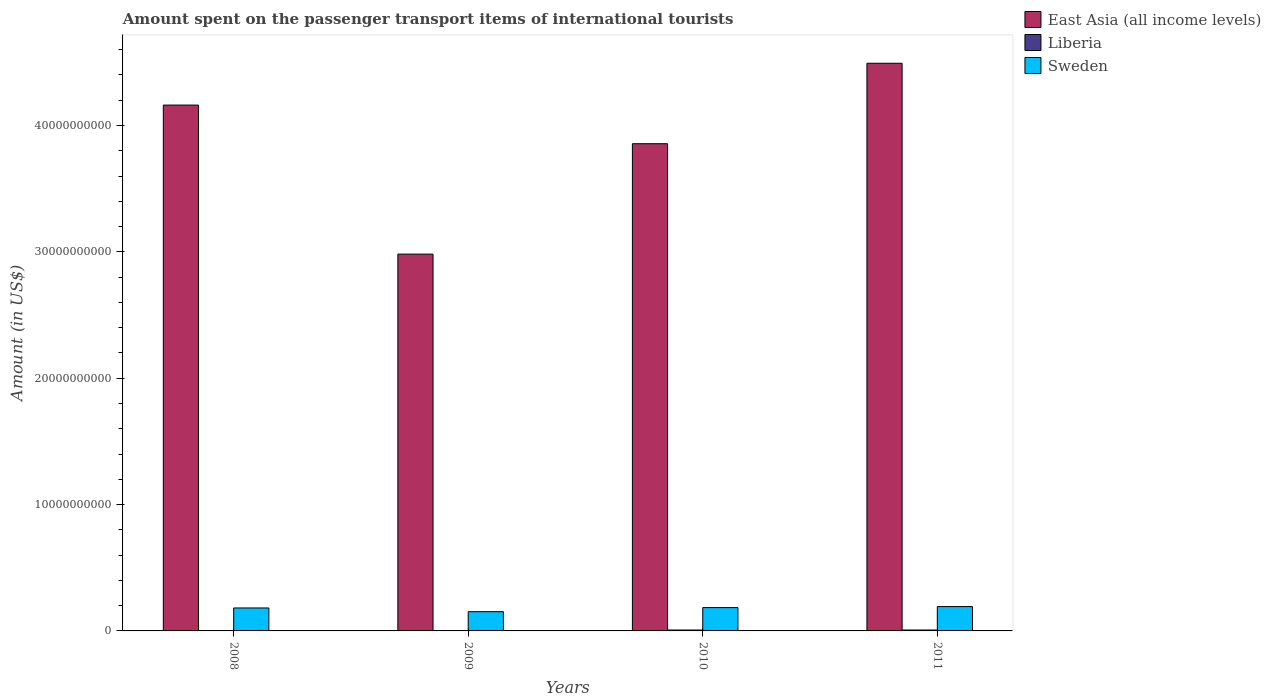Are the number of bars on each tick of the X-axis equal?
Offer a very short reply. Yes. How many bars are there on the 3rd tick from the left?
Offer a terse response. 3. What is the label of the 1st group of bars from the left?
Offer a terse response. 2008. What is the amount spent on the passenger transport items of international tourists in East Asia (all income levels) in 2008?
Your answer should be very brief. 4.16e+1. Across all years, what is the maximum amount spent on the passenger transport items of international tourists in Sweden?
Your response must be concise. 1.93e+09. Across all years, what is the minimum amount spent on the passenger transport items of international tourists in East Asia (all income levels)?
Your answer should be very brief. 2.98e+1. In which year was the amount spent on the passenger transport items of international tourists in Sweden maximum?
Give a very brief answer. 2011. What is the total amount spent on the passenger transport items of international tourists in Sweden in the graph?
Your response must be concise. 7.11e+09. What is the difference between the amount spent on the passenger transport items of international tourists in East Asia (all income levels) in 2010 and that in 2011?
Offer a very short reply. -6.37e+09. What is the difference between the amount spent on the passenger transport items of international tourists in East Asia (all income levels) in 2008 and the amount spent on the passenger transport items of international tourists in Sweden in 2010?
Make the answer very short. 3.98e+1. What is the average amount spent on the passenger transport items of international tourists in Liberia per year?
Provide a succinct answer. 4.82e+07. In the year 2009, what is the difference between the amount spent on the passenger transport items of international tourists in Liberia and amount spent on the passenger transport items of international tourists in Sweden?
Your answer should be very brief. -1.50e+09. In how many years, is the amount spent on the passenger transport items of international tourists in Sweden greater than 4000000000 US$?
Make the answer very short. 0. What is the ratio of the amount spent on the passenger transport items of international tourists in Sweden in 2008 to that in 2009?
Your response must be concise. 1.19. Is the amount spent on the passenger transport items of international tourists in East Asia (all income levels) in 2009 less than that in 2010?
Keep it short and to the point. Yes. Is the difference between the amount spent on the passenger transport items of international tourists in Liberia in 2009 and 2011 greater than the difference between the amount spent on the passenger transport items of international tourists in Sweden in 2009 and 2011?
Give a very brief answer. Yes. What is the difference between the highest and the second highest amount spent on the passenger transport items of international tourists in East Asia (all income levels)?
Ensure brevity in your answer.  3.31e+09. What is the difference between the highest and the lowest amount spent on the passenger transport items of international tourists in Sweden?
Provide a succinct answer. 4.03e+08. In how many years, is the amount spent on the passenger transport items of international tourists in Sweden greater than the average amount spent on the passenger transport items of international tourists in Sweden taken over all years?
Keep it short and to the point. 3. Is the sum of the amount spent on the passenger transport items of international tourists in East Asia (all income levels) in 2008 and 2011 greater than the maximum amount spent on the passenger transport items of international tourists in Liberia across all years?
Provide a short and direct response. Yes. What does the 2nd bar from the right in 2010 represents?
Provide a succinct answer. Liberia. How many bars are there?
Keep it short and to the point. 12. Are all the bars in the graph horizontal?
Your answer should be very brief. No. Are the values on the major ticks of Y-axis written in scientific E-notation?
Give a very brief answer. No. Does the graph contain any zero values?
Provide a succinct answer. No. Where does the legend appear in the graph?
Make the answer very short. Top right. What is the title of the graph?
Your answer should be compact. Amount spent on the passenger transport items of international tourists. Does "Euro area" appear as one of the legend labels in the graph?
Provide a short and direct response. No. What is the label or title of the Y-axis?
Offer a terse response. Amount (in US$). What is the Amount (in US$) in East Asia (all income levels) in 2008?
Your response must be concise. 4.16e+1. What is the Amount (in US$) in Liberia in 2008?
Offer a very short reply. 2.80e+07. What is the Amount (in US$) in Sweden in 2008?
Your answer should be compact. 1.82e+09. What is the Amount (in US$) in East Asia (all income levels) in 2009?
Provide a short and direct response. 2.98e+1. What is the Amount (in US$) in Liberia in 2009?
Your answer should be very brief. 2.20e+07. What is the Amount (in US$) of Sweden in 2009?
Ensure brevity in your answer.  1.52e+09. What is the Amount (in US$) of East Asia (all income levels) in 2010?
Offer a very short reply. 3.86e+1. What is the Amount (in US$) of Liberia in 2010?
Your response must be concise. 7.10e+07. What is the Amount (in US$) in Sweden in 2010?
Your answer should be very brief. 1.85e+09. What is the Amount (in US$) of East Asia (all income levels) in 2011?
Provide a short and direct response. 4.49e+1. What is the Amount (in US$) in Liberia in 2011?
Provide a short and direct response. 7.20e+07. What is the Amount (in US$) in Sweden in 2011?
Offer a terse response. 1.93e+09. Across all years, what is the maximum Amount (in US$) in East Asia (all income levels)?
Offer a very short reply. 4.49e+1. Across all years, what is the maximum Amount (in US$) in Liberia?
Ensure brevity in your answer.  7.20e+07. Across all years, what is the maximum Amount (in US$) of Sweden?
Your answer should be compact. 1.93e+09. Across all years, what is the minimum Amount (in US$) in East Asia (all income levels)?
Your response must be concise. 2.98e+1. Across all years, what is the minimum Amount (in US$) in Liberia?
Offer a terse response. 2.20e+07. Across all years, what is the minimum Amount (in US$) in Sweden?
Your answer should be compact. 1.52e+09. What is the total Amount (in US$) in East Asia (all income levels) in the graph?
Make the answer very short. 1.55e+11. What is the total Amount (in US$) of Liberia in the graph?
Offer a terse response. 1.93e+08. What is the total Amount (in US$) in Sweden in the graph?
Your answer should be compact. 7.11e+09. What is the difference between the Amount (in US$) of East Asia (all income levels) in 2008 and that in 2009?
Make the answer very short. 1.18e+1. What is the difference between the Amount (in US$) of Sweden in 2008 and that in 2009?
Provide a succinct answer. 2.94e+08. What is the difference between the Amount (in US$) of East Asia (all income levels) in 2008 and that in 2010?
Offer a very short reply. 3.06e+09. What is the difference between the Amount (in US$) in Liberia in 2008 and that in 2010?
Your response must be concise. -4.30e+07. What is the difference between the Amount (in US$) in Sweden in 2008 and that in 2010?
Make the answer very short. -3.00e+07. What is the difference between the Amount (in US$) of East Asia (all income levels) in 2008 and that in 2011?
Provide a succinct answer. -3.31e+09. What is the difference between the Amount (in US$) of Liberia in 2008 and that in 2011?
Keep it short and to the point. -4.40e+07. What is the difference between the Amount (in US$) in Sweden in 2008 and that in 2011?
Offer a very short reply. -1.09e+08. What is the difference between the Amount (in US$) of East Asia (all income levels) in 2009 and that in 2010?
Give a very brief answer. -8.74e+09. What is the difference between the Amount (in US$) in Liberia in 2009 and that in 2010?
Provide a succinct answer. -4.90e+07. What is the difference between the Amount (in US$) in Sweden in 2009 and that in 2010?
Provide a succinct answer. -3.24e+08. What is the difference between the Amount (in US$) of East Asia (all income levels) in 2009 and that in 2011?
Your answer should be very brief. -1.51e+1. What is the difference between the Amount (in US$) in Liberia in 2009 and that in 2011?
Your answer should be compact. -5.00e+07. What is the difference between the Amount (in US$) in Sweden in 2009 and that in 2011?
Offer a terse response. -4.03e+08. What is the difference between the Amount (in US$) of East Asia (all income levels) in 2010 and that in 2011?
Give a very brief answer. -6.37e+09. What is the difference between the Amount (in US$) in Liberia in 2010 and that in 2011?
Ensure brevity in your answer.  -1.00e+06. What is the difference between the Amount (in US$) of Sweden in 2010 and that in 2011?
Offer a terse response. -7.90e+07. What is the difference between the Amount (in US$) in East Asia (all income levels) in 2008 and the Amount (in US$) in Liberia in 2009?
Offer a terse response. 4.16e+1. What is the difference between the Amount (in US$) in East Asia (all income levels) in 2008 and the Amount (in US$) in Sweden in 2009?
Your answer should be compact. 4.01e+1. What is the difference between the Amount (in US$) of Liberia in 2008 and the Amount (in US$) of Sweden in 2009?
Make the answer very short. -1.50e+09. What is the difference between the Amount (in US$) in East Asia (all income levels) in 2008 and the Amount (in US$) in Liberia in 2010?
Make the answer very short. 4.15e+1. What is the difference between the Amount (in US$) in East Asia (all income levels) in 2008 and the Amount (in US$) in Sweden in 2010?
Offer a terse response. 3.98e+1. What is the difference between the Amount (in US$) of Liberia in 2008 and the Amount (in US$) of Sweden in 2010?
Provide a short and direct response. -1.82e+09. What is the difference between the Amount (in US$) in East Asia (all income levels) in 2008 and the Amount (in US$) in Liberia in 2011?
Your answer should be very brief. 4.15e+1. What is the difference between the Amount (in US$) in East Asia (all income levels) in 2008 and the Amount (in US$) in Sweden in 2011?
Provide a succinct answer. 3.97e+1. What is the difference between the Amount (in US$) of Liberia in 2008 and the Amount (in US$) of Sweden in 2011?
Provide a short and direct response. -1.90e+09. What is the difference between the Amount (in US$) of East Asia (all income levels) in 2009 and the Amount (in US$) of Liberia in 2010?
Your answer should be compact. 2.97e+1. What is the difference between the Amount (in US$) of East Asia (all income levels) in 2009 and the Amount (in US$) of Sweden in 2010?
Your answer should be compact. 2.80e+1. What is the difference between the Amount (in US$) in Liberia in 2009 and the Amount (in US$) in Sweden in 2010?
Provide a succinct answer. -1.82e+09. What is the difference between the Amount (in US$) of East Asia (all income levels) in 2009 and the Amount (in US$) of Liberia in 2011?
Offer a terse response. 2.97e+1. What is the difference between the Amount (in US$) in East Asia (all income levels) in 2009 and the Amount (in US$) in Sweden in 2011?
Provide a short and direct response. 2.79e+1. What is the difference between the Amount (in US$) of Liberia in 2009 and the Amount (in US$) of Sweden in 2011?
Your response must be concise. -1.90e+09. What is the difference between the Amount (in US$) of East Asia (all income levels) in 2010 and the Amount (in US$) of Liberia in 2011?
Your answer should be compact. 3.85e+1. What is the difference between the Amount (in US$) of East Asia (all income levels) in 2010 and the Amount (in US$) of Sweden in 2011?
Your answer should be very brief. 3.66e+1. What is the difference between the Amount (in US$) of Liberia in 2010 and the Amount (in US$) of Sweden in 2011?
Your response must be concise. -1.86e+09. What is the average Amount (in US$) of East Asia (all income levels) per year?
Give a very brief answer. 3.87e+1. What is the average Amount (in US$) in Liberia per year?
Provide a succinct answer. 4.82e+07. What is the average Amount (in US$) of Sweden per year?
Your answer should be very brief. 1.78e+09. In the year 2008, what is the difference between the Amount (in US$) in East Asia (all income levels) and Amount (in US$) in Liberia?
Your answer should be compact. 4.16e+1. In the year 2008, what is the difference between the Amount (in US$) in East Asia (all income levels) and Amount (in US$) in Sweden?
Your answer should be very brief. 3.98e+1. In the year 2008, what is the difference between the Amount (in US$) in Liberia and Amount (in US$) in Sweden?
Provide a short and direct response. -1.79e+09. In the year 2009, what is the difference between the Amount (in US$) of East Asia (all income levels) and Amount (in US$) of Liberia?
Give a very brief answer. 2.98e+1. In the year 2009, what is the difference between the Amount (in US$) in East Asia (all income levels) and Amount (in US$) in Sweden?
Provide a succinct answer. 2.83e+1. In the year 2009, what is the difference between the Amount (in US$) in Liberia and Amount (in US$) in Sweden?
Keep it short and to the point. -1.50e+09. In the year 2010, what is the difference between the Amount (in US$) in East Asia (all income levels) and Amount (in US$) in Liberia?
Offer a terse response. 3.85e+1. In the year 2010, what is the difference between the Amount (in US$) of East Asia (all income levels) and Amount (in US$) of Sweden?
Offer a very short reply. 3.67e+1. In the year 2010, what is the difference between the Amount (in US$) in Liberia and Amount (in US$) in Sweden?
Provide a short and direct response. -1.78e+09. In the year 2011, what is the difference between the Amount (in US$) in East Asia (all income levels) and Amount (in US$) in Liberia?
Give a very brief answer. 4.49e+1. In the year 2011, what is the difference between the Amount (in US$) in East Asia (all income levels) and Amount (in US$) in Sweden?
Your answer should be very brief. 4.30e+1. In the year 2011, what is the difference between the Amount (in US$) in Liberia and Amount (in US$) in Sweden?
Make the answer very short. -1.85e+09. What is the ratio of the Amount (in US$) in East Asia (all income levels) in 2008 to that in 2009?
Offer a very short reply. 1.4. What is the ratio of the Amount (in US$) in Liberia in 2008 to that in 2009?
Your answer should be very brief. 1.27. What is the ratio of the Amount (in US$) in Sweden in 2008 to that in 2009?
Provide a succinct answer. 1.19. What is the ratio of the Amount (in US$) of East Asia (all income levels) in 2008 to that in 2010?
Keep it short and to the point. 1.08. What is the ratio of the Amount (in US$) of Liberia in 2008 to that in 2010?
Your response must be concise. 0.39. What is the ratio of the Amount (in US$) in Sweden in 2008 to that in 2010?
Ensure brevity in your answer.  0.98. What is the ratio of the Amount (in US$) in East Asia (all income levels) in 2008 to that in 2011?
Keep it short and to the point. 0.93. What is the ratio of the Amount (in US$) of Liberia in 2008 to that in 2011?
Offer a terse response. 0.39. What is the ratio of the Amount (in US$) in Sweden in 2008 to that in 2011?
Offer a terse response. 0.94. What is the ratio of the Amount (in US$) of East Asia (all income levels) in 2009 to that in 2010?
Your response must be concise. 0.77. What is the ratio of the Amount (in US$) in Liberia in 2009 to that in 2010?
Give a very brief answer. 0.31. What is the ratio of the Amount (in US$) of Sweden in 2009 to that in 2010?
Your answer should be very brief. 0.82. What is the ratio of the Amount (in US$) of East Asia (all income levels) in 2009 to that in 2011?
Your response must be concise. 0.66. What is the ratio of the Amount (in US$) in Liberia in 2009 to that in 2011?
Offer a terse response. 0.31. What is the ratio of the Amount (in US$) in Sweden in 2009 to that in 2011?
Offer a terse response. 0.79. What is the ratio of the Amount (in US$) in East Asia (all income levels) in 2010 to that in 2011?
Keep it short and to the point. 0.86. What is the ratio of the Amount (in US$) of Liberia in 2010 to that in 2011?
Your answer should be very brief. 0.99. What is the difference between the highest and the second highest Amount (in US$) of East Asia (all income levels)?
Offer a terse response. 3.31e+09. What is the difference between the highest and the second highest Amount (in US$) in Sweden?
Provide a short and direct response. 7.90e+07. What is the difference between the highest and the lowest Amount (in US$) in East Asia (all income levels)?
Offer a very short reply. 1.51e+1. What is the difference between the highest and the lowest Amount (in US$) in Liberia?
Give a very brief answer. 5.00e+07. What is the difference between the highest and the lowest Amount (in US$) of Sweden?
Offer a very short reply. 4.03e+08. 